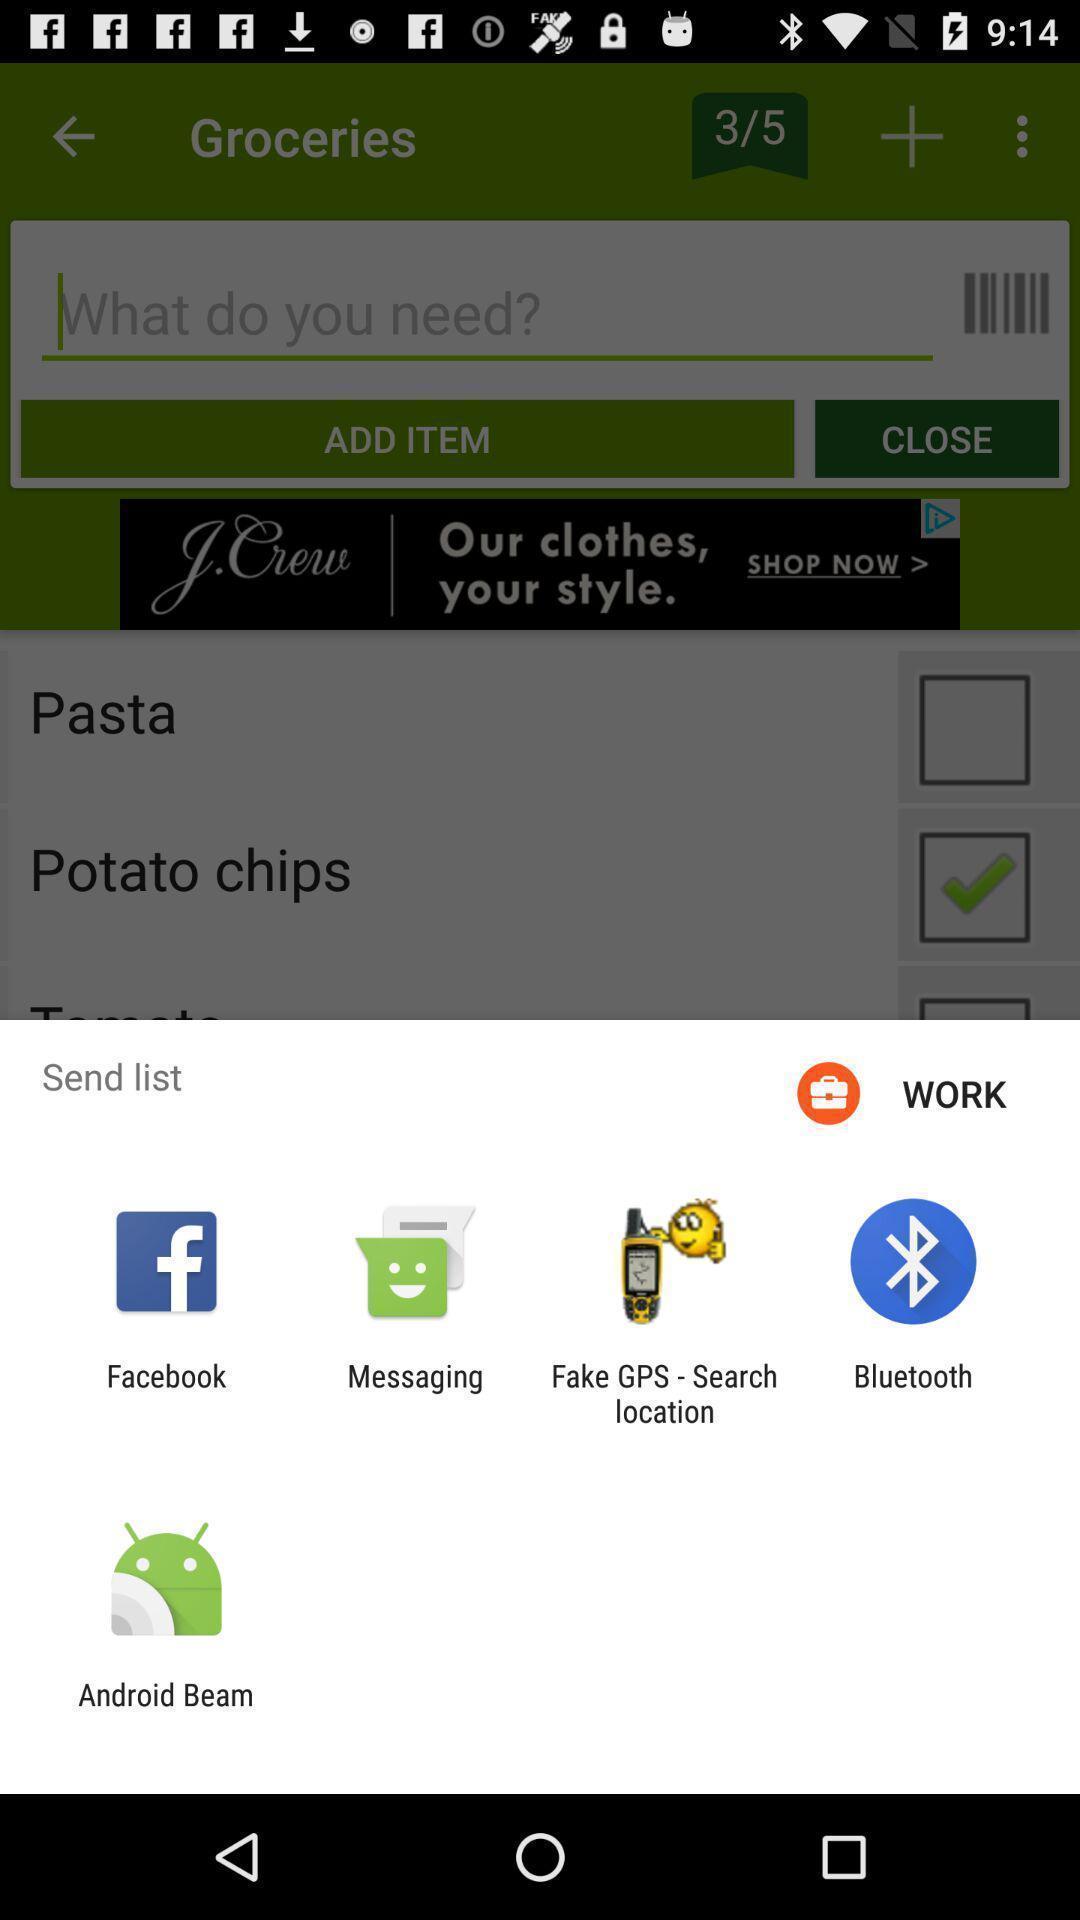Summarize the main components in this picture. Pop up page displaying various apps for sharing info. 